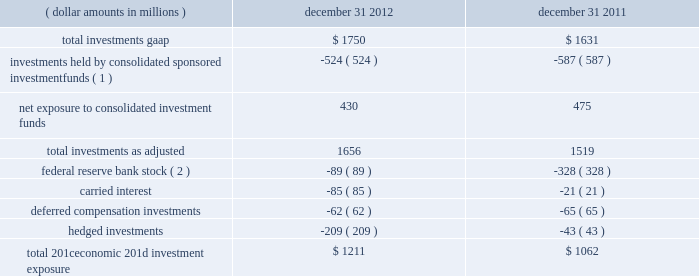The company further presents total net 201ceconomic 201d investment exposure , net of deferred compensation investments and hedged investments , to reflect another gauge for investors as the economic impact of investments held pursuant to deferred compensation arrangements is substantially offset by a change in compensation expense and the impact of hedged investments is substantially mitigated by total return swap hedges .
Carried interest capital allocations are excluded as there is no impact to blackrock 2019s stockholders 2019 equity until such amounts are realized as performance fees .
Finally , the company 2019s regulatory investment in federal reserve bank stock , which is not subject to market or interest rate risk , is excluded from the company 2019s net economic investment exposure .
( dollar amounts in millions ) december 31 , december 31 .
Total 201ceconomic 201d investment exposure .
$ 1211 $ 1062 ( 1 ) at december 31 , 2012 and december 31 , 2011 , approximately $ 524 million and $ 587 million , respectively , of blackrock 2019s total gaap investments were maintained in sponsored investment funds that were deemed to be controlled by blackrock in accordance with gaap , and , therefore , are consolidated even though blackrock may not economically own a majority of such funds .
( 2 ) the decrease of $ 239 million related to a lower holding requirement of federal reserve bank stock held by blackrock institutional trust company , n.a .
( 201cbtc 201d ) .
Total investments , as adjusted , at december 31 , 2012 increased $ 137 million from december 31 , 2011 , resulting from $ 765 million of purchases/capital contributions , $ 185 million from positive market valuations and earnings from equity method investments , and $ 64 million from net additional carried interest capital allocations , partially offset by $ 742 million of sales/maturities and $ 135 million of distributions representing return of capital and return on investments. .
In 2012 , what net exposure amounted to consolidated investment funds amounted to what percent of the investments held by consolidated sponsored investment funds? 
Computations: (430 / 524)
Answer: 0.82061. The company further presents total net 201ceconomic 201d investment exposure , net of deferred compensation investments and hedged investments , to reflect another gauge for investors as the economic impact of investments held pursuant to deferred compensation arrangements is substantially offset by a change in compensation expense and the impact of hedged investments is substantially mitigated by total return swap hedges .
Carried interest capital allocations are excluded as there is no impact to blackrock 2019s stockholders 2019 equity until such amounts are realized as performance fees .
Finally , the company 2019s regulatory investment in federal reserve bank stock , which is not subject to market or interest rate risk , is excluded from the company 2019s net economic investment exposure .
( dollar amounts in millions ) december 31 , december 31 .
Total 201ceconomic 201d investment exposure .
$ 1211 $ 1062 ( 1 ) at december 31 , 2012 and december 31 , 2011 , approximately $ 524 million and $ 587 million , respectively , of blackrock 2019s total gaap investments were maintained in sponsored investment funds that were deemed to be controlled by blackrock in accordance with gaap , and , therefore , are consolidated even though blackrock may not economically own a majority of such funds .
( 2 ) the decrease of $ 239 million related to a lower holding requirement of federal reserve bank stock held by blackrock institutional trust company , n.a .
( 201cbtc 201d ) .
Total investments , as adjusted , at december 31 , 2012 increased $ 137 million from december 31 , 2011 , resulting from $ 765 million of purchases/capital contributions , $ 185 million from positive market valuations and earnings from equity method investments , and $ 64 million from net additional carried interest capital allocations , partially offset by $ 742 million of sales/maturities and $ 135 million of distributions representing return of capital and return on investments. .
In 2012 , investments held by consolidated sponsored investment funds reduced the company's investment exposure by what percent? 
Computations: (524 / (1211 + 524))
Answer: 0.30202. 